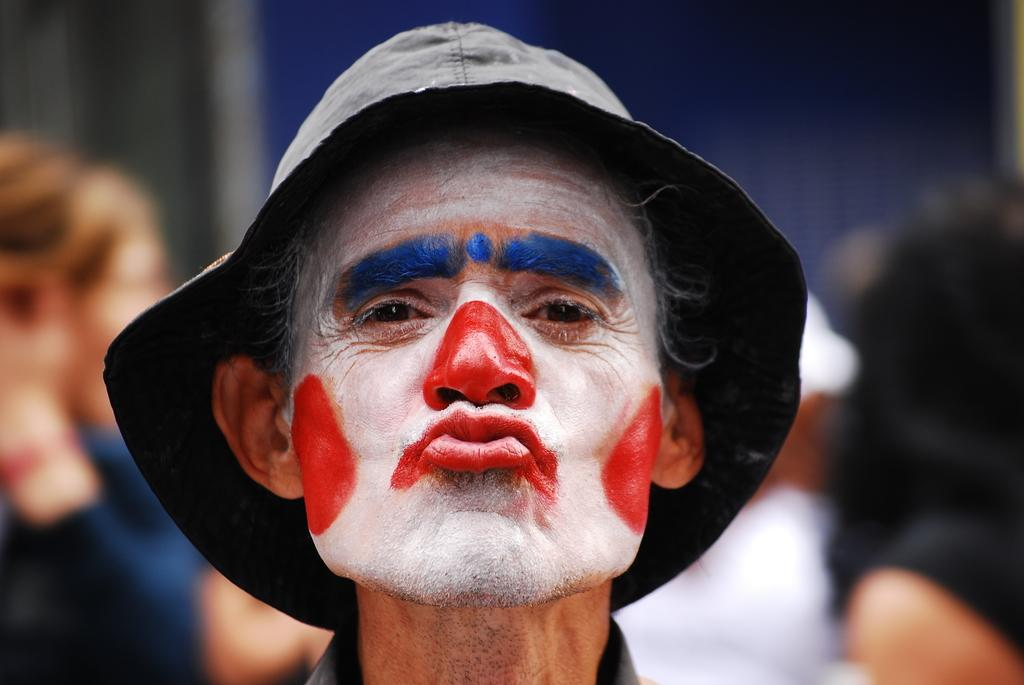What is the main subject in the foreground of the image? There is a person in the foreground of the image. What is the person wearing on their head? The person is wearing a cap. Can you describe the background of the image? There are people in the background of the image. Are there any cobwebs visible in the image? There is no mention of cobwebs in the provided facts, so it cannot be determined if any are present in the image. 